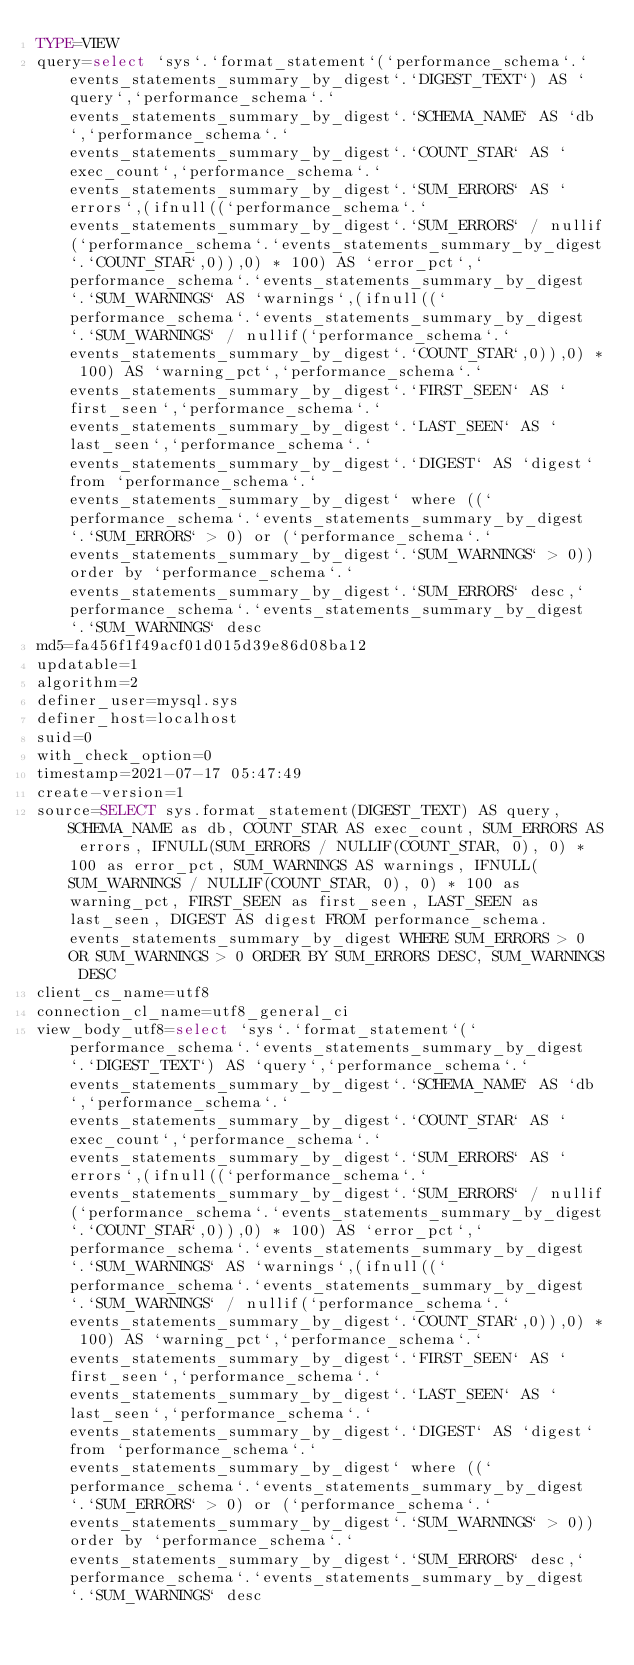<code> <loc_0><loc_0><loc_500><loc_500><_VisualBasic_>TYPE=VIEW
query=select `sys`.`format_statement`(`performance_schema`.`events_statements_summary_by_digest`.`DIGEST_TEXT`) AS `query`,`performance_schema`.`events_statements_summary_by_digest`.`SCHEMA_NAME` AS `db`,`performance_schema`.`events_statements_summary_by_digest`.`COUNT_STAR` AS `exec_count`,`performance_schema`.`events_statements_summary_by_digest`.`SUM_ERRORS` AS `errors`,(ifnull((`performance_schema`.`events_statements_summary_by_digest`.`SUM_ERRORS` / nullif(`performance_schema`.`events_statements_summary_by_digest`.`COUNT_STAR`,0)),0) * 100) AS `error_pct`,`performance_schema`.`events_statements_summary_by_digest`.`SUM_WARNINGS` AS `warnings`,(ifnull((`performance_schema`.`events_statements_summary_by_digest`.`SUM_WARNINGS` / nullif(`performance_schema`.`events_statements_summary_by_digest`.`COUNT_STAR`,0)),0) * 100) AS `warning_pct`,`performance_schema`.`events_statements_summary_by_digest`.`FIRST_SEEN` AS `first_seen`,`performance_schema`.`events_statements_summary_by_digest`.`LAST_SEEN` AS `last_seen`,`performance_schema`.`events_statements_summary_by_digest`.`DIGEST` AS `digest` from `performance_schema`.`events_statements_summary_by_digest` where ((`performance_schema`.`events_statements_summary_by_digest`.`SUM_ERRORS` > 0) or (`performance_schema`.`events_statements_summary_by_digest`.`SUM_WARNINGS` > 0)) order by `performance_schema`.`events_statements_summary_by_digest`.`SUM_ERRORS` desc,`performance_schema`.`events_statements_summary_by_digest`.`SUM_WARNINGS` desc
md5=fa456f1f49acf01d015d39e86d08ba12
updatable=1
algorithm=2
definer_user=mysql.sys
definer_host=localhost
suid=0
with_check_option=0
timestamp=2021-07-17 05:47:49
create-version=1
source=SELECT sys.format_statement(DIGEST_TEXT) AS query, SCHEMA_NAME as db, COUNT_STAR AS exec_count, SUM_ERRORS AS errors, IFNULL(SUM_ERRORS / NULLIF(COUNT_STAR, 0), 0) * 100 as error_pct, SUM_WARNINGS AS warnings, IFNULL(SUM_WARNINGS / NULLIF(COUNT_STAR, 0), 0) * 100 as warning_pct, FIRST_SEEN as first_seen, LAST_SEEN as last_seen, DIGEST AS digest FROM performance_schema.events_statements_summary_by_digest WHERE SUM_ERRORS > 0 OR SUM_WARNINGS > 0 ORDER BY SUM_ERRORS DESC, SUM_WARNINGS DESC
client_cs_name=utf8
connection_cl_name=utf8_general_ci
view_body_utf8=select `sys`.`format_statement`(`performance_schema`.`events_statements_summary_by_digest`.`DIGEST_TEXT`) AS `query`,`performance_schema`.`events_statements_summary_by_digest`.`SCHEMA_NAME` AS `db`,`performance_schema`.`events_statements_summary_by_digest`.`COUNT_STAR` AS `exec_count`,`performance_schema`.`events_statements_summary_by_digest`.`SUM_ERRORS` AS `errors`,(ifnull((`performance_schema`.`events_statements_summary_by_digest`.`SUM_ERRORS` / nullif(`performance_schema`.`events_statements_summary_by_digest`.`COUNT_STAR`,0)),0) * 100) AS `error_pct`,`performance_schema`.`events_statements_summary_by_digest`.`SUM_WARNINGS` AS `warnings`,(ifnull((`performance_schema`.`events_statements_summary_by_digest`.`SUM_WARNINGS` / nullif(`performance_schema`.`events_statements_summary_by_digest`.`COUNT_STAR`,0)),0) * 100) AS `warning_pct`,`performance_schema`.`events_statements_summary_by_digest`.`FIRST_SEEN` AS `first_seen`,`performance_schema`.`events_statements_summary_by_digest`.`LAST_SEEN` AS `last_seen`,`performance_schema`.`events_statements_summary_by_digest`.`DIGEST` AS `digest` from `performance_schema`.`events_statements_summary_by_digest` where ((`performance_schema`.`events_statements_summary_by_digest`.`SUM_ERRORS` > 0) or (`performance_schema`.`events_statements_summary_by_digest`.`SUM_WARNINGS` > 0)) order by `performance_schema`.`events_statements_summary_by_digest`.`SUM_ERRORS` desc,`performance_schema`.`events_statements_summary_by_digest`.`SUM_WARNINGS` desc
</code> 